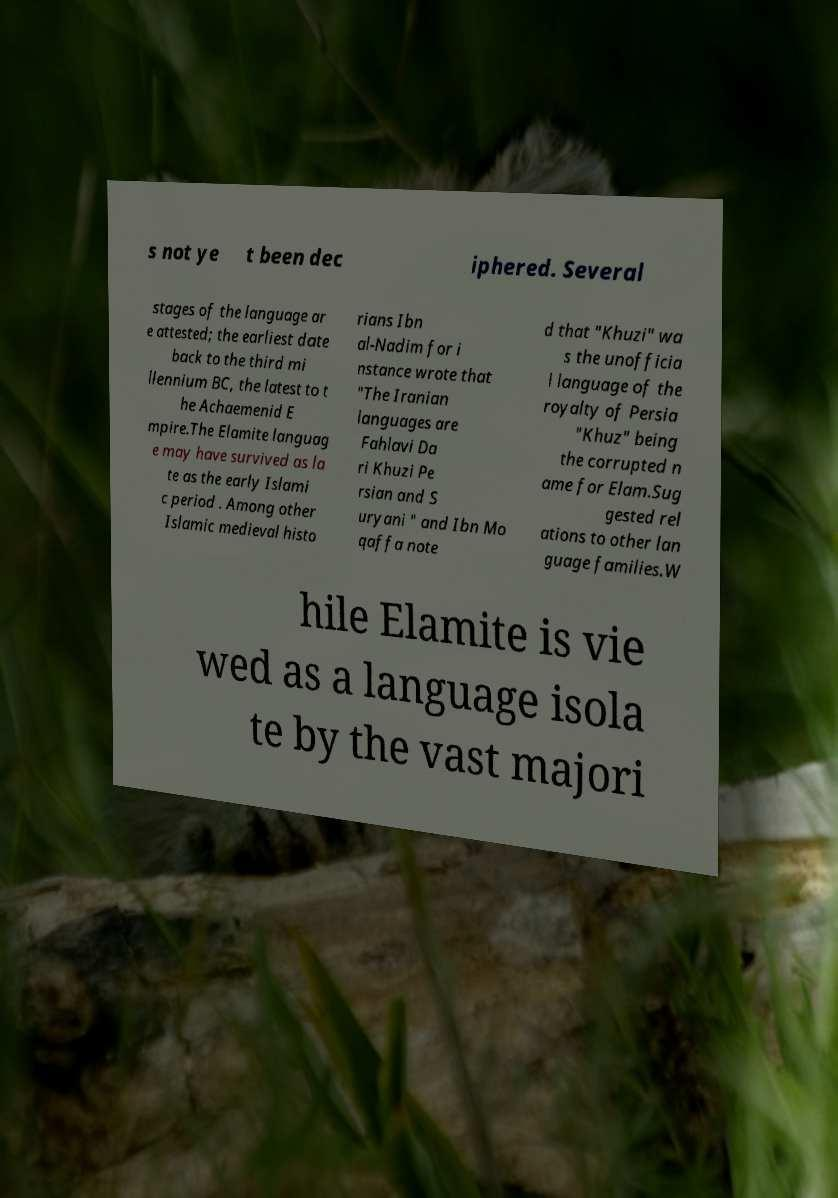I need the written content from this picture converted into text. Can you do that? s not ye t been dec iphered. Several stages of the language ar e attested; the earliest date back to the third mi llennium BC, the latest to t he Achaemenid E mpire.The Elamite languag e may have survived as la te as the early Islami c period . Among other Islamic medieval histo rians Ibn al-Nadim for i nstance wrote that "The Iranian languages are Fahlavi Da ri Khuzi Pe rsian and S uryani " and Ibn Mo qaffa note d that "Khuzi" wa s the unofficia l language of the royalty of Persia "Khuz" being the corrupted n ame for Elam.Sug gested rel ations to other lan guage families.W hile Elamite is vie wed as a language isola te by the vast majori 